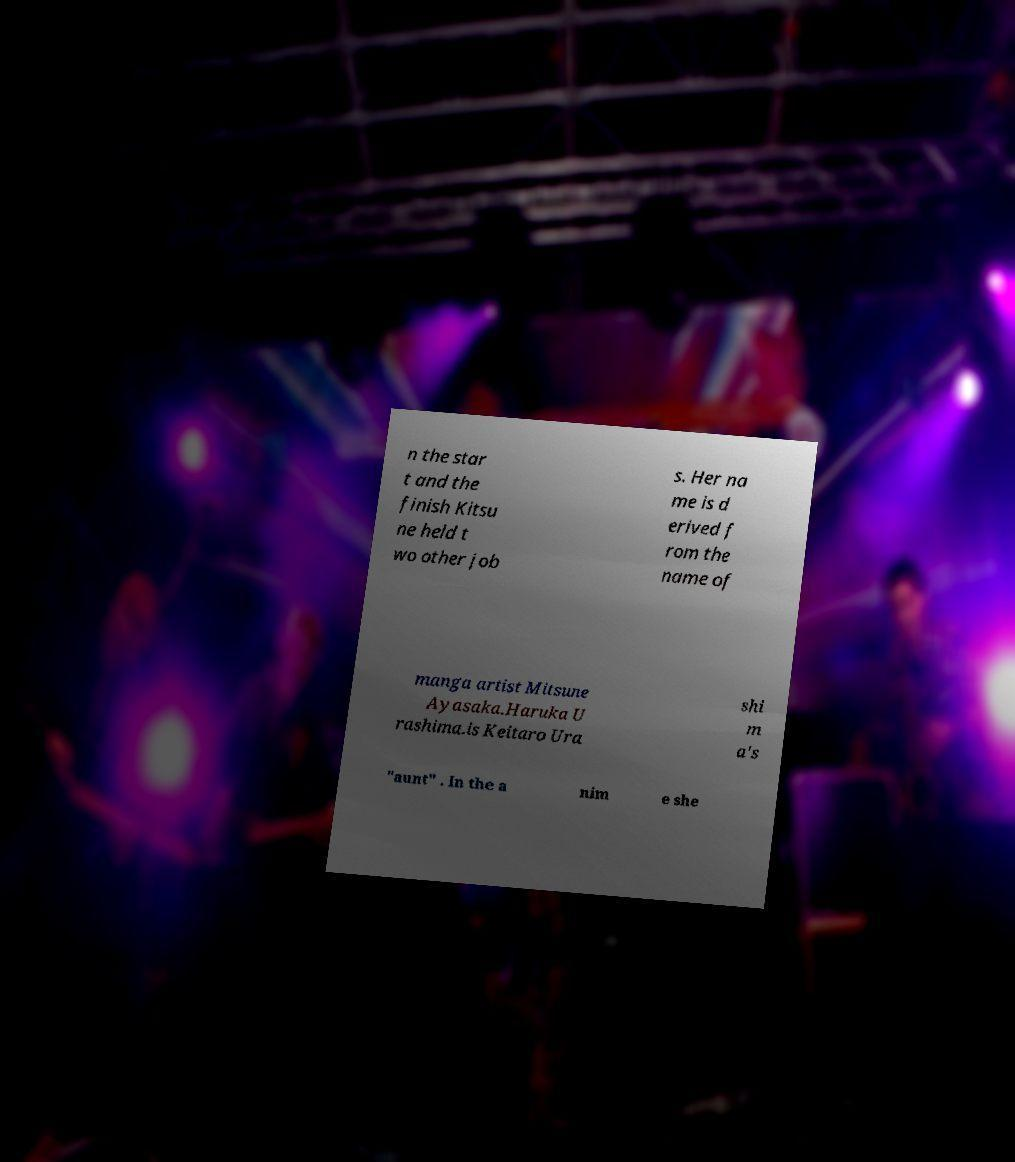What messages or text are displayed in this image? I need them in a readable, typed format. n the star t and the finish Kitsu ne held t wo other job s. Her na me is d erived f rom the name of manga artist Mitsune Ayasaka.Haruka U rashima.is Keitaro Ura shi m a's "aunt" . In the a nim e she 